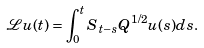Convert formula to latex. <formula><loc_0><loc_0><loc_500><loc_500>\mathcal { L } u ( t ) = \int _ { 0 } ^ { t } S _ { t - s } Q ^ { 1 / 2 } u ( s ) d s .</formula> 